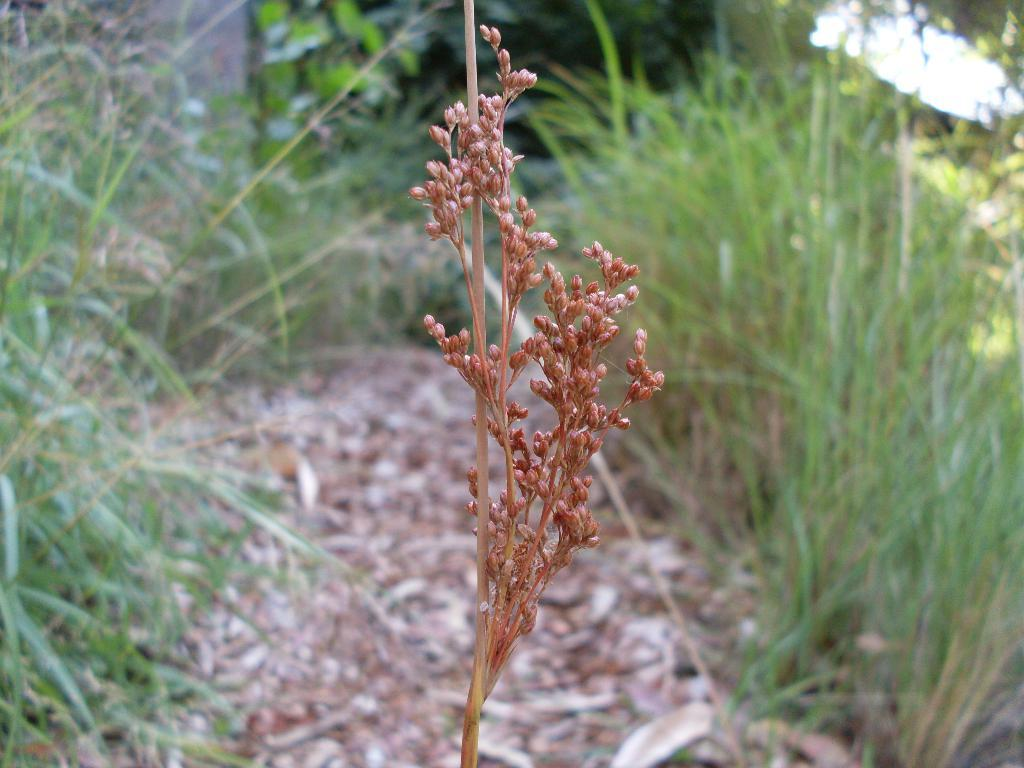What type of vegetation can be seen in the image? There is grass visible in the image. What else can be seen in the image besides grass? There are leaves visible in the image. How many chickens are sitting on the tub in the image? There are no chickens or tubs present in the image. 